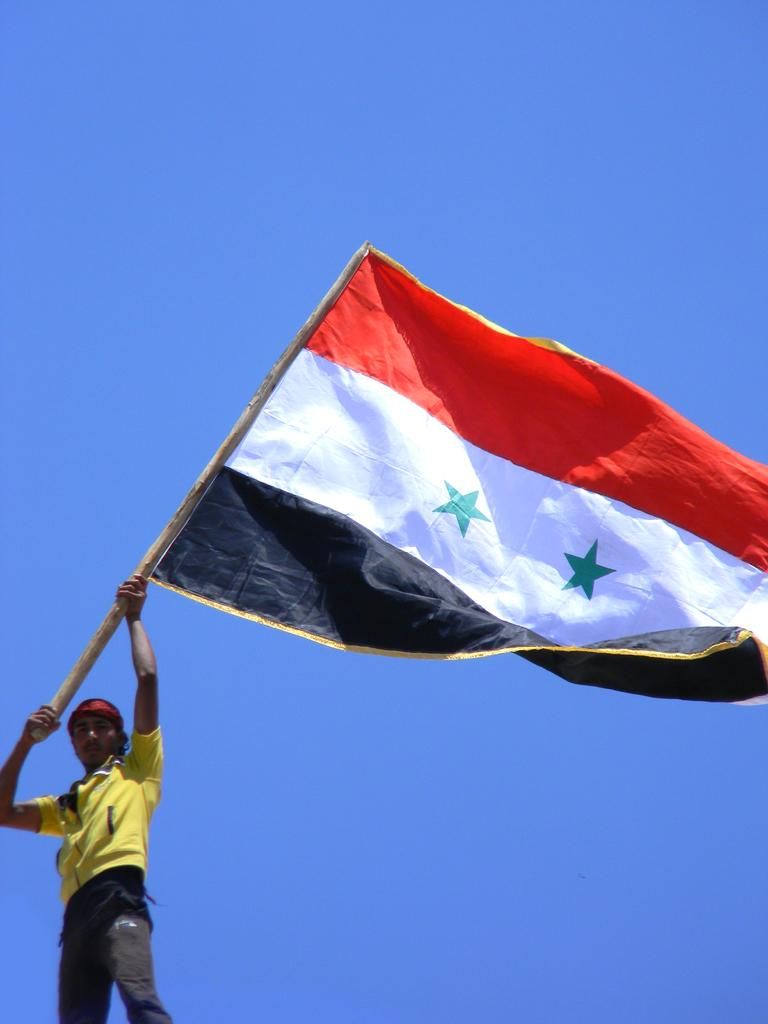Where is the man located in the image? The man is in the bottom left corner of the image. What is the man doing in the image? The man is standing in the image. What is the man holding in the image? The man is holding a flag in the image. What can be seen behind the man in the image? There is sky visible behind the man in the image. What flavor of ice cream is the man eating in the image? There is no ice cream present in the image, and the man is not eating anything. 